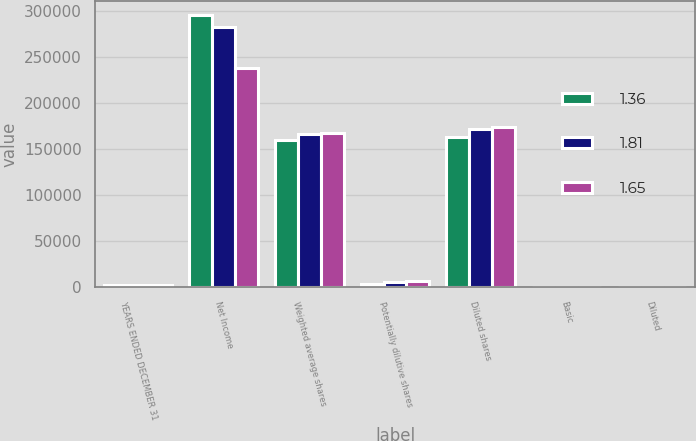<chart> <loc_0><loc_0><loc_500><loc_500><stacked_bar_chart><ecel><fcel>YEARS ENDED DECEMBER 31<fcel>Net Income<fcel>Weighted average shares<fcel>Potentially dilutive shares<fcel>Diluted shares<fcel>Basic<fcel>Diluted<nl><fcel>1.36<fcel>2007<fcel>296212<fcel>159767<fcel>3712<fcel>163479<fcel>1.85<fcel>1.81<nl><fcel>1.81<fcel>2006<fcel>283178<fcel>166003<fcel>5709<fcel>171712<fcel>1.71<fcel>1.65<nl><fcel>1.65<fcel>2005<fcel>237870<fcel>167664<fcel>6718<fcel>174382<fcel>1.42<fcel>1.36<nl></chart> 